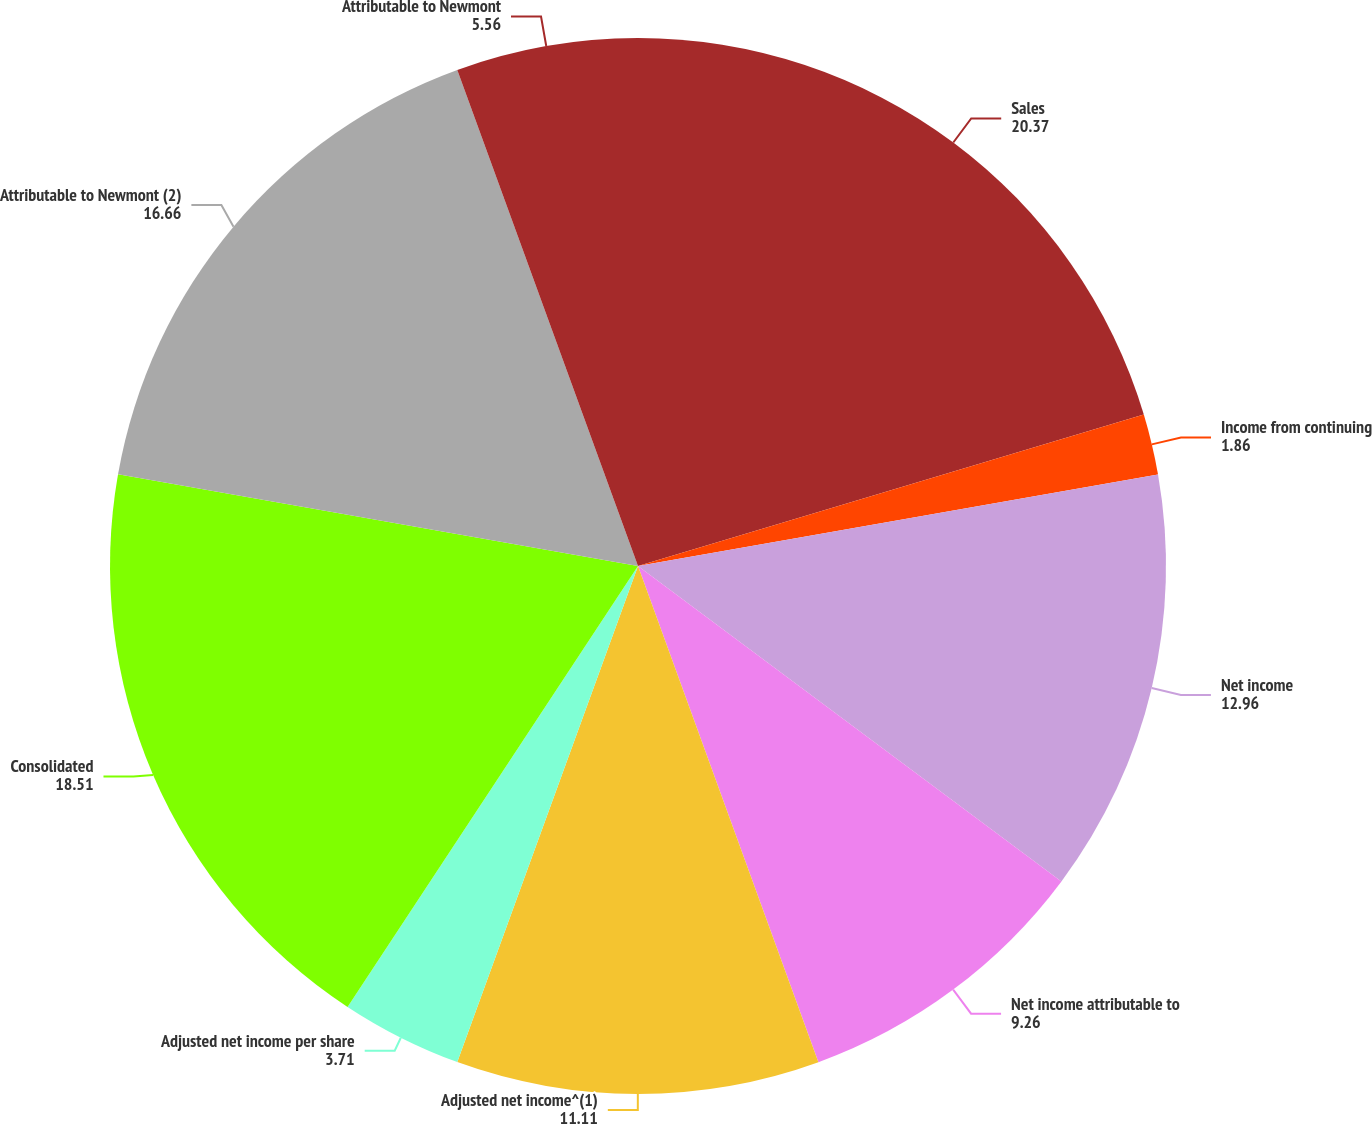Convert chart. <chart><loc_0><loc_0><loc_500><loc_500><pie_chart><fcel>Sales<fcel>Income from continuing<fcel>Net income<fcel>Net income attributable to<fcel>Adjusted net income^(1)<fcel>Adjusted net income per share<fcel>Consolidated<fcel>Attributable to Newmont (2)<fcel>Attributable to Newmont<nl><fcel>20.37%<fcel>1.86%<fcel>12.96%<fcel>9.26%<fcel>11.11%<fcel>3.71%<fcel>18.51%<fcel>16.66%<fcel>5.56%<nl></chart> 